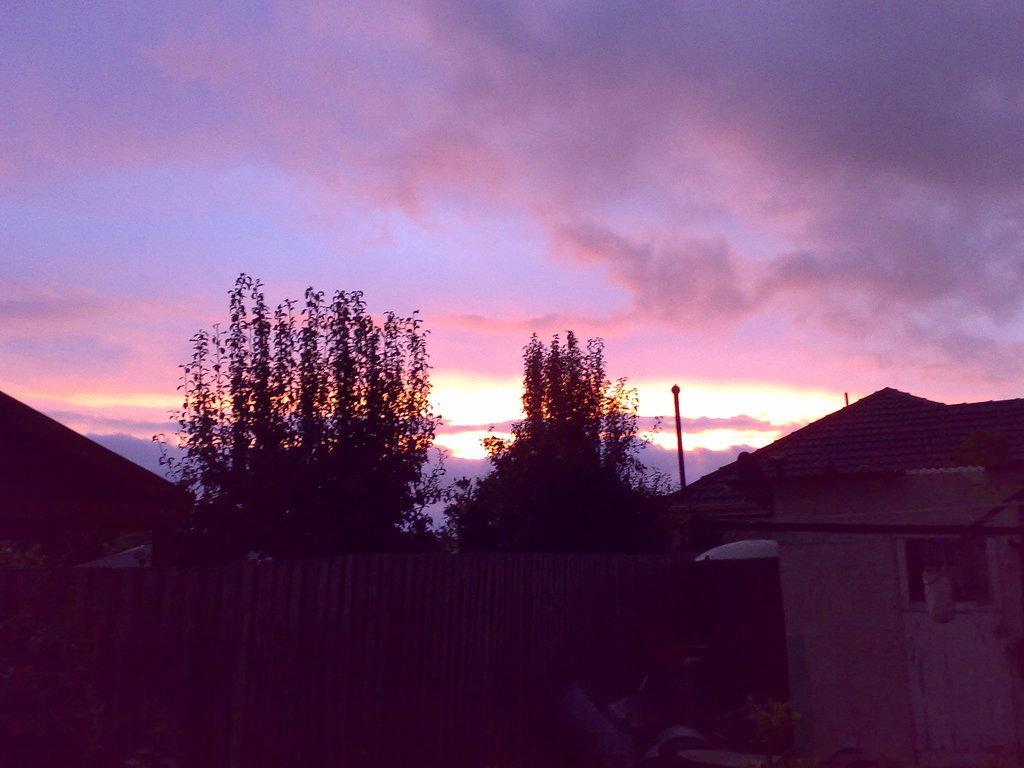How would you summarize this image in a sentence or two? In this image I see the fencing over here and I see the trees and houses. In the background I see the sky which is a bit cloudy and I see that it is a bit dark over here. 